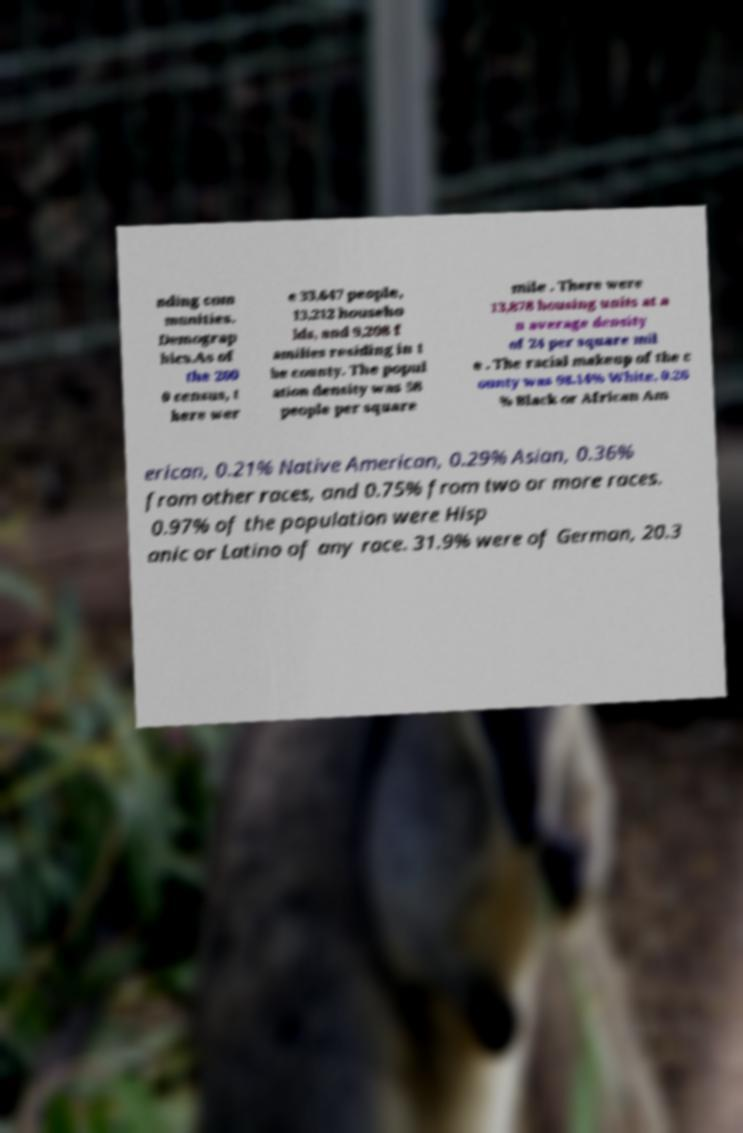For documentation purposes, I need the text within this image transcribed. Could you provide that? nding com munities. Demograp hics.As of the 200 0 census, t here wer e 33,647 people, 13,212 househo lds, and 9,208 f amilies residing in t he county. The popul ation density was 58 people per square mile . There were 13,878 housing units at a n average density of 24 per square mil e . The racial makeup of the c ounty was 98.14% White, 0.26 % Black or African Am erican, 0.21% Native American, 0.29% Asian, 0.36% from other races, and 0.75% from two or more races. 0.97% of the population were Hisp anic or Latino of any race. 31.9% were of German, 20.3 